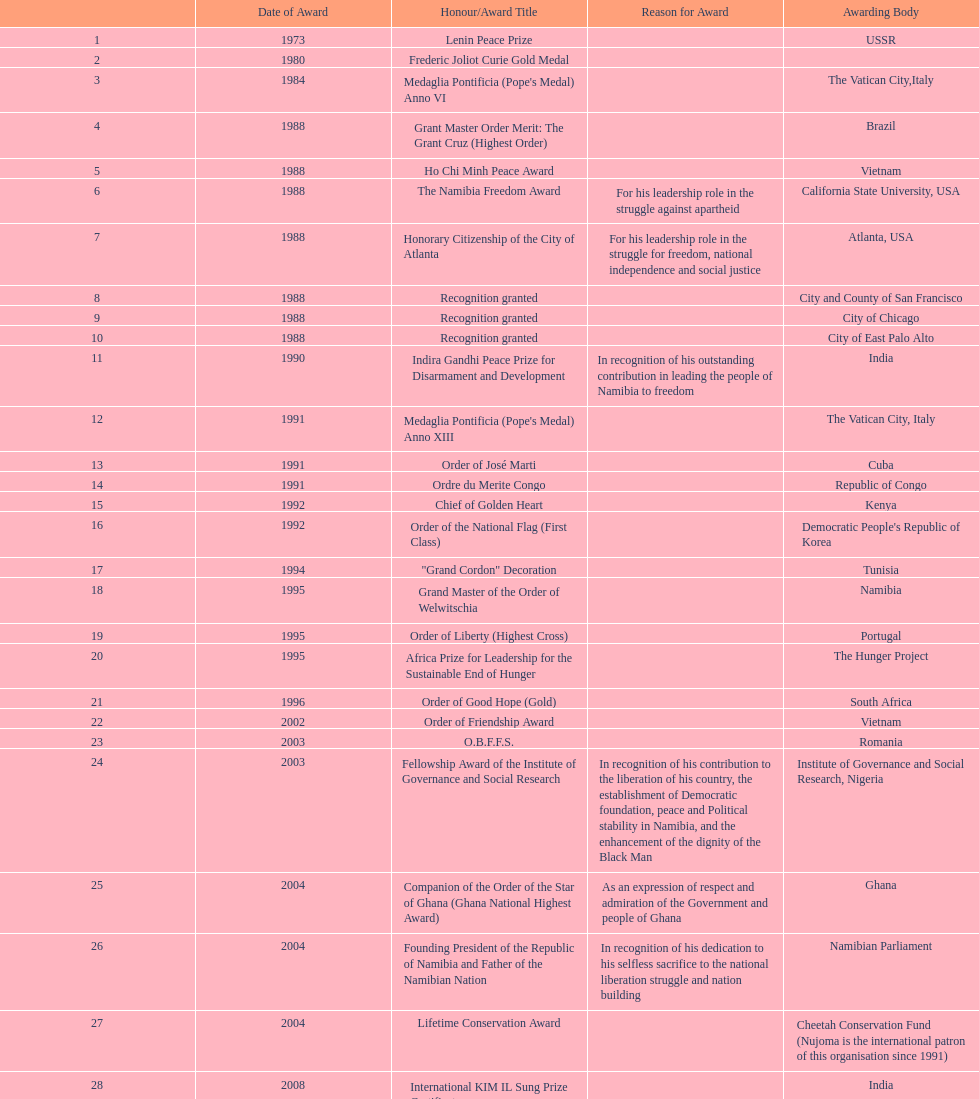The number of times "recognition granted" was the received award? 3. 